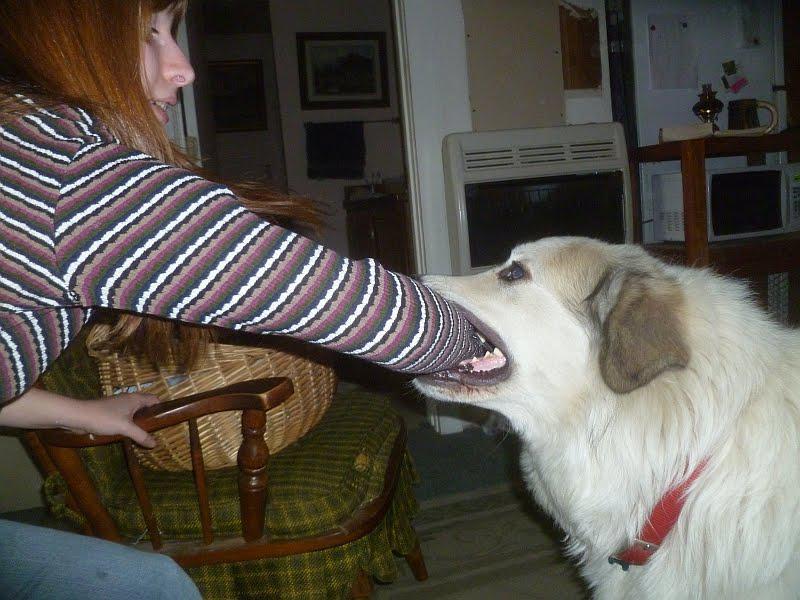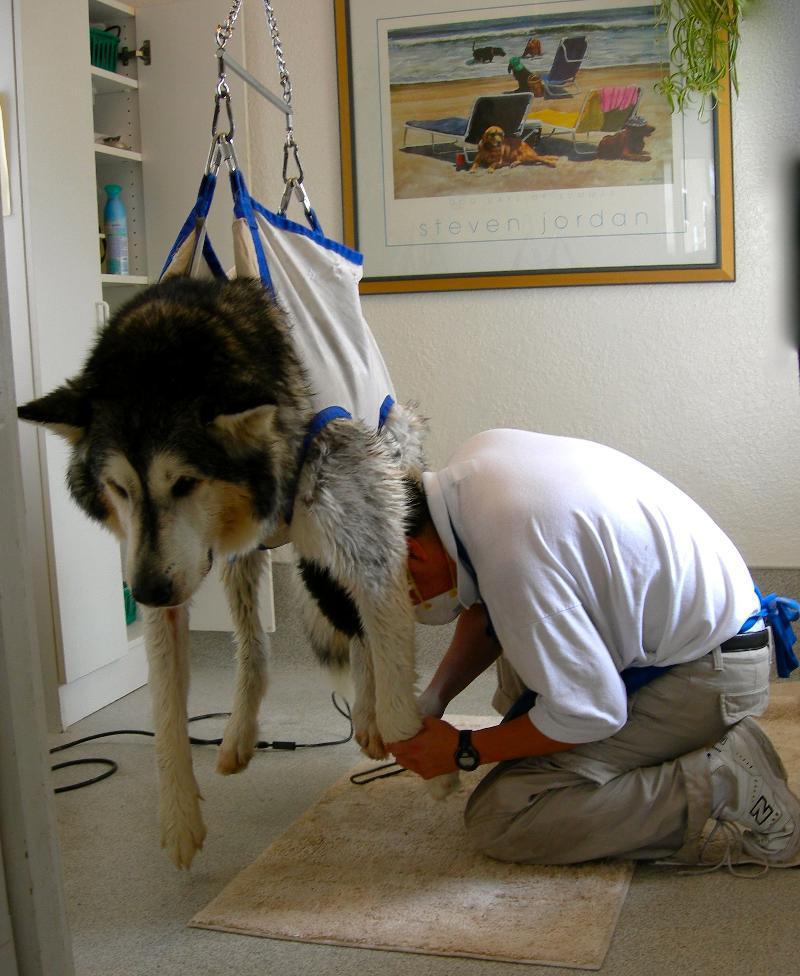The first image is the image on the left, the second image is the image on the right. Examine the images to the left and right. Is the description "An image shows exactly one person behind two white dogs." accurate? Answer yes or no. No. The first image is the image on the left, the second image is the image on the right. Analyze the images presented: Is the assertion "Each image shows one person in an indoors setting with a large dog." valid? Answer yes or no. Yes. 